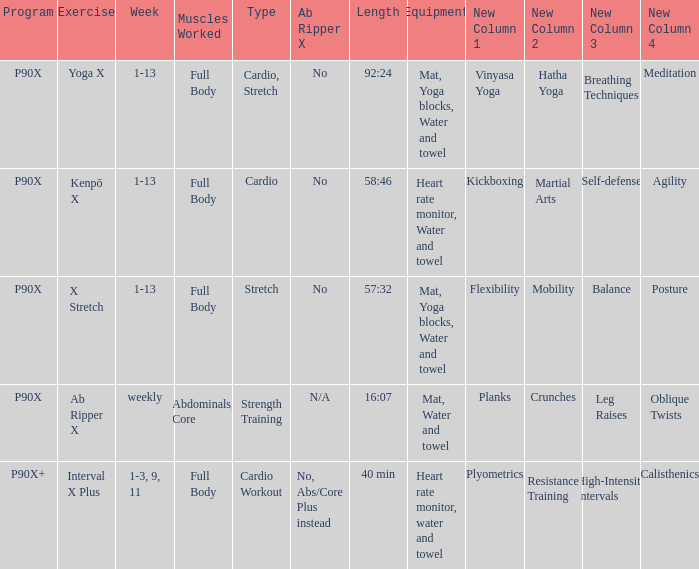During which week is the cardio workout type scheduled? 1-3, 9, 11. 